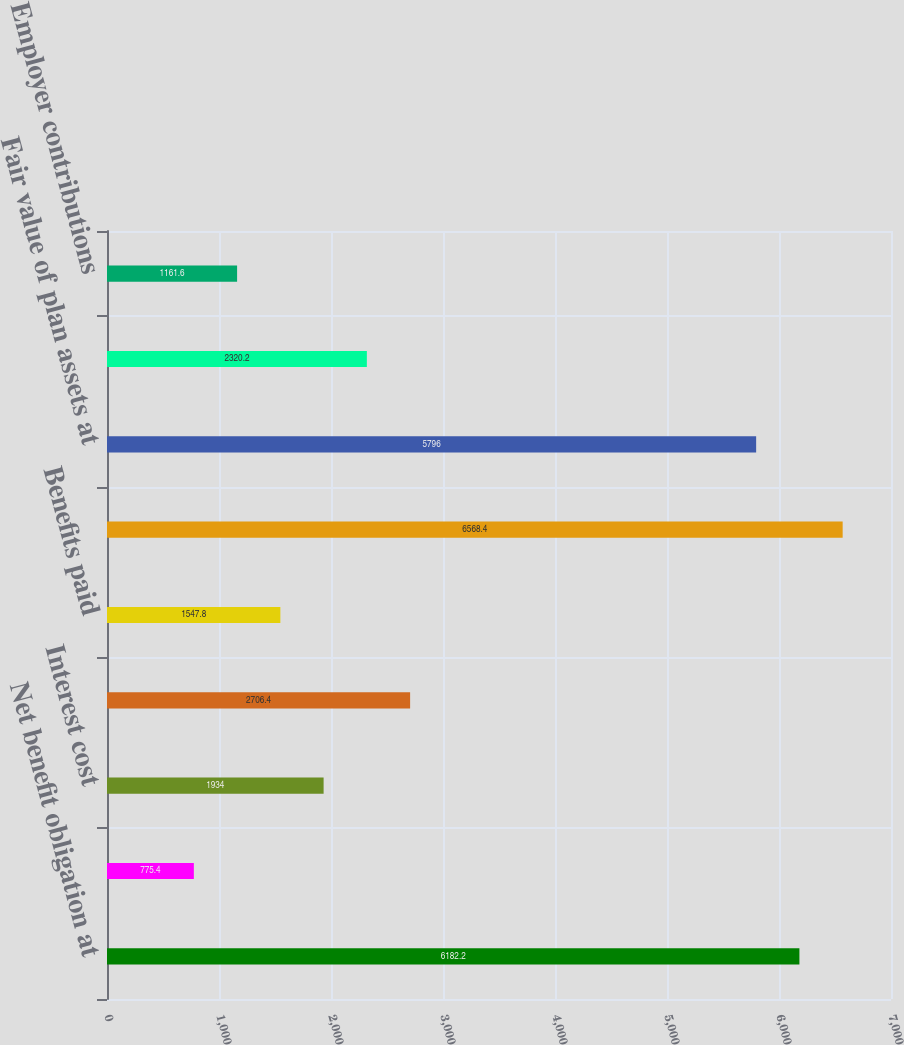Convert chart. <chart><loc_0><loc_0><loc_500><loc_500><bar_chart><fcel>Net benefit obligation at<fcel>Service cost<fcel>Interest cost<fcel>Actuarial loss<fcel>Benefits paid<fcel>Net benefit obligation at end<fcel>Fair value of plan assets at<fcel>Actual return on plan assets<fcel>Employer contributions<nl><fcel>6182.2<fcel>775.4<fcel>1934<fcel>2706.4<fcel>1547.8<fcel>6568.4<fcel>5796<fcel>2320.2<fcel>1161.6<nl></chart> 